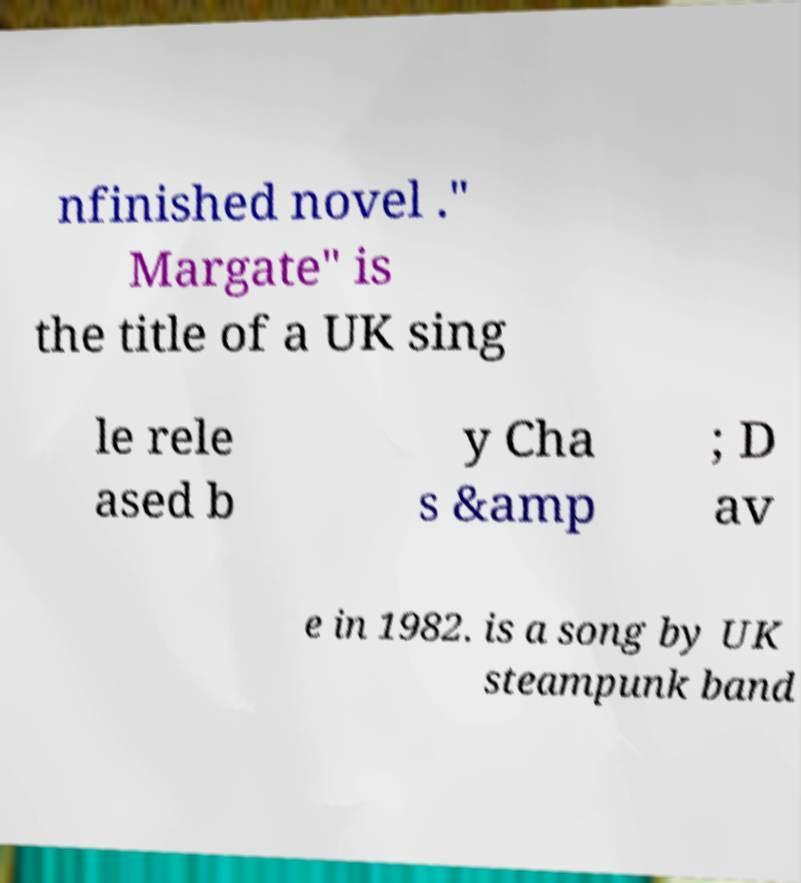What messages or text are displayed in this image? I need them in a readable, typed format. nfinished novel ." Margate" is the title of a UK sing le rele ased b y Cha s &amp ; D av e in 1982. is a song by UK steampunk band 